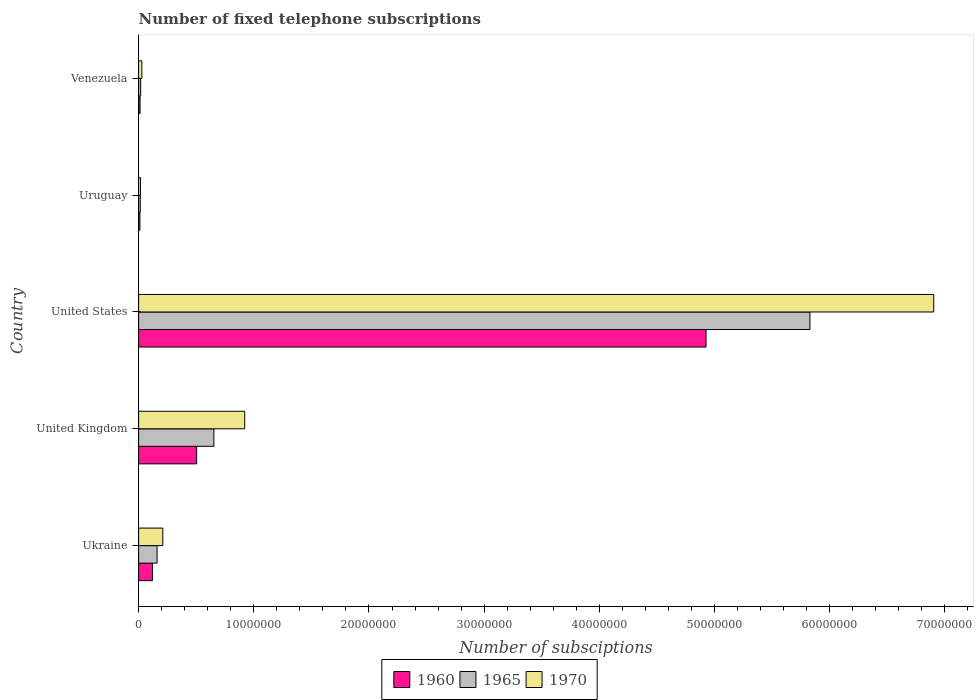How many groups of bars are there?
Your answer should be very brief. 5. Are the number of bars on each tick of the Y-axis equal?
Your response must be concise. Yes. How many bars are there on the 5th tick from the bottom?
Your answer should be compact. 3. In how many cases, is the number of bars for a given country not equal to the number of legend labels?
Give a very brief answer. 0. Across all countries, what is the maximum number of fixed telephone subscriptions in 1960?
Your response must be concise. 4.93e+07. In which country was the number of fixed telephone subscriptions in 1965 minimum?
Your answer should be compact. Uruguay. What is the total number of fixed telephone subscriptions in 1970 in the graph?
Your answer should be compact. 8.08e+07. What is the difference between the number of fixed telephone subscriptions in 1965 in Ukraine and that in United States?
Offer a terse response. -5.67e+07. What is the difference between the number of fixed telephone subscriptions in 1960 in United States and the number of fixed telephone subscriptions in 1965 in Uruguay?
Your answer should be very brief. 4.91e+07. What is the average number of fixed telephone subscriptions in 1960 per country?
Your response must be concise. 1.11e+07. What is the difference between the number of fixed telephone subscriptions in 1965 and number of fixed telephone subscriptions in 1960 in United States?
Your response must be concise. 9.02e+06. What is the ratio of the number of fixed telephone subscriptions in 1970 in United Kingdom to that in Venezuela?
Offer a very short reply. 33.02. What is the difference between the highest and the second highest number of fixed telephone subscriptions in 1965?
Offer a very short reply. 5.18e+07. What is the difference between the highest and the lowest number of fixed telephone subscriptions in 1970?
Your answer should be compact. 6.89e+07. Is the sum of the number of fixed telephone subscriptions in 1970 in United Kingdom and Venezuela greater than the maximum number of fixed telephone subscriptions in 1960 across all countries?
Provide a succinct answer. No. What does the 1st bar from the top in Ukraine represents?
Provide a short and direct response. 1970. What does the 3rd bar from the bottom in Ukraine represents?
Your answer should be very brief. 1970. Are all the bars in the graph horizontal?
Your answer should be very brief. Yes. How many countries are there in the graph?
Your answer should be very brief. 5. What is the difference between two consecutive major ticks on the X-axis?
Give a very brief answer. 1.00e+07. Are the values on the major ticks of X-axis written in scientific E-notation?
Your response must be concise. No. Does the graph contain any zero values?
Provide a succinct answer. No. Does the graph contain grids?
Your answer should be compact. No. Where does the legend appear in the graph?
Your response must be concise. Bottom center. How are the legend labels stacked?
Your response must be concise. Horizontal. What is the title of the graph?
Your response must be concise. Number of fixed telephone subscriptions. Does "1968" appear as one of the legend labels in the graph?
Keep it short and to the point. No. What is the label or title of the X-axis?
Offer a very short reply. Number of subsciptions. What is the label or title of the Y-axis?
Offer a terse response. Country. What is the Number of subsciptions in 1960 in Ukraine?
Provide a short and direct response. 1.20e+06. What is the Number of subsciptions of 1965 in Ukraine?
Offer a very short reply. 1.60e+06. What is the Number of subsciptions in 1970 in Ukraine?
Make the answer very short. 2.10e+06. What is the Number of subsciptions of 1960 in United Kingdom?
Give a very brief answer. 5.04e+06. What is the Number of subsciptions in 1965 in United Kingdom?
Keep it short and to the point. 6.53e+06. What is the Number of subsciptions in 1970 in United Kingdom?
Offer a very short reply. 9.21e+06. What is the Number of subsciptions of 1960 in United States?
Your answer should be compact. 4.93e+07. What is the Number of subsciptions of 1965 in United States?
Provide a short and direct response. 5.83e+07. What is the Number of subsciptions in 1970 in United States?
Offer a very short reply. 6.90e+07. What is the Number of subsciptions of 1965 in Uruguay?
Offer a terse response. 1.42e+05. What is the Number of subsciptions of 1960 in Venezuela?
Keep it short and to the point. 1.25e+05. What is the Number of subsciptions of 1965 in Venezuela?
Your answer should be compact. 1.78e+05. What is the Number of subsciptions in 1970 in Venezuela?
Your response must be concise. 2.79e+05. Across all countries, what is the maximum Number of subsciptions in 1960?
Give a very brief answer. 4.93e+07. Across all countries, what is the maximum Number of subsciptions in 1965?
Provide a succinct answer. 5.83e+07. Across all countries, what is the maximum Number of subsciptions of 1970?
Offer a terse response. 6.90e+07. Across all countries, what is the minimum Number of subsciptions in 1960?
Keep it short and to the point. 1.10e+05. Across all countries, what is the minimum Number of subsciptions in 1965?
Make the answer very short. 1.42e+05. Across all countries, what is the minimum Number of subsciptions of 1970?
Keep it short and to the point. 1.60e+05. What is the total Number of subsciptions of 1960 in the graph?
Offer a very short reply. 5.57e+07. What is the total Number of subsciptions of 1965 in the graph?
Provide a succinct answer. 6.67e+07. What is the total Number of subsciptions in 1970 in the graph?
Offer a terse response. 8.08e+07. What is the difference between the Number of subsciptions in 1960 in Ukraine and that in United Kingdom?
Give a very brief answer. -3.84e+06. What is the difference between the Number of subsciptions of 1965 in Ukraine and that in United Kingdom?
Offer a very short reply. -4.93e+06. What is the difference between the Number of subsciptions in 1970 in Ukraine and that in United Kingdom?
Offer a very short reply. -7.11e+06. What is the difference between the Number of subsciptions of 1960 in Ukraine and that in United States?
Offer a very short reply. -4.81e+07. What is the difference between the Number of subsciptions of 1965 in Ukraine and that in United States?
Keep it short and to the point. -5.67e+07. What is the difference between the Number of subsciptions in 1970 in Ukraine and that in United States?
Provide a short and direct response. -6.69e+07. What is the difference between the Number of subsciptions of 1960 in Ukraine and that in Uruguay?
Your response must be concise. 1.09e+06. What is the difference between the Number of subsciptions of 1965 in Ukraine and that in Uruguay?
Ensure brevity in your answer.  1.46e+06. What is the difference between the Number of subsciptions in 1970 in Ukraine and that in Uruguay?
Provide a short and direct response. 1.94e+06. What is the difference between the Number of subsciptions of 1960 in Ukraine and that in Venezuela?
Offer a very short reply. 1.08e+06. What is the difference between the Number of subsciptions in 1965 in Ukraine and that in Venezuela?
Give a very brief answer. 1.42e+06. What is the difference between the Number of subsciptions of 1970 in Ukraine and that in Venezuela?
Offer a terse response. 1.82e+06. What is the difference between the Number of subsciptions in 1960 in United Kingdom and that in United States?
Provide a succinct answer. -4.42e+07. What is the difference between the Number of subsciptions in 1965 in United Kingdom and that in United States?
Give a very brief answer. -5.18e+07. What is the difference between the Number of subsciptions in 1970 in United Kingdom and that in United States?
Provide a short and direct response. -5.98e+07. What is the difference between the Number of subsciptions in 1960 in United Kingdom and that in Uruguay?
Your answer should be very brief. 4.93e+06. What is the difference between the Number of subsciptions of 1965 in United Kingdom and that in Uruguay?
Offer a very short reply. 6.39e+06. What is the difference between the Number of subsciptions of 1970 in United Kingdom and that in Uruguay?
Make the answer very short. 9.05e+06. What is the difference between the Number of subsciptions in 1960 in United Kingdom and that in Venezuela?
Provide a succinct answer. 4.91e+06. What is the difference between the Number of subsciptions of 1965 in United Kingdom and that in Venezuela?
Your answer should be very brief. 6.36e+06. What is the difference between the Number of subsciptions of 1970 in United Kingdom and that in Venezuela?
Offer a terse response. 8.93e+06. What is the difference between the Number of subsciptions of 1960 in United States and that in Uruguay?
Offer a terse response. 4.92e+07. What is the difference between the Number of subsciptions in 1965 in United States and that in Uruguay?
Make the answer very short. 5.81e+07. What is the difference between the Number of subsciptions in 1970 in United States and that in Uruguay?
Keep it short and to the point. 6.89e+07. What is the difference between the Number of subsciptions in 1960 in United States and that in Venezuela?
Offer a terse response. 4.91e+07. What is the difference between the Number of subsciptions of 1965 in United States and that in Venezuela?
Your answer should be very brief. 5.81e+07. What is the difference between the Number of subsciptions of 1970 in United States and that in Venezuela?
Your response must be concise. 6.88e+07. What is the difference between the Number of subsciptions in 1960 in Uruguay and that in Venezuela?
Your response must be concise. -1.50e+04. What is the difference between the Number of subsciptions in 1965 in Uruguay and that in Venezuela?
Ensure brevity in your answer.  -3.60e+04. What is the difference between the Number of subsciptions of 1970 in Uruguay and that in Venezuela?
Offer a very short reply. -1.19e+05. What is the difference between the Number of subsciptions in 1960 in Ukraine and the Number of subsciptions in 1965 in United Kingdom?
Give a very brief answer. -5.33e+06. What is the difference between the Number of subsciptions in 1960 in Ukraine and the Number of subsciptions in 1970 in United Kingdom?
Provide a succinct answer. -8.01e+06. What is the difference between the Number of subsciptions of 1965 in Ukraine and the Number of subsciptions of 1970 in United Kingdom?
Provide a succinct answer. -7.61e+06. What is the difference between the Number of subsciptions of 1960 in Ukraine and the Number of subsciptions of 1965 in United States?
Your response must be concise. -5.71e+07. What is the difference between the Number of subsciptions in 1960 in Ukraine and the Number of subsciptions in 1970 in United States?
Provide a succinct answer. -6.78e+07. What is the difference between the Number of subsciptions in 1965 in Ukraine and the Number of subsciptions in 1970 in United States?
Offer a very short reply. -6.74e+07. What is the difference between the Number of subsciptions of 1960 in Ukraine and the Number of subsciptions of 1965 in Uruguay?
Offer a terse response. 1.06e+06. What is the difference between the Number of subsciptions of 1960 in Ukraine and the Number of subsciptions of 1970 in Uruguay?
Offer a very short reply. 1.04e+06. What is the difference between the Number of subsciptions in 1965 in Ukraine and the Number of subsciptions in 1970 in Uruguay?
Your response must be concise. 1.44e+06. What is the difference between the Number of subsciptions of 1960 in Ukraine and the Number of subsciptions of 1965 in Venezuela?
Ensure brevity in your answer.  1.02e+06. What is the difference between the Number of subsciptions in 1960 in Ukraine and the Number of subsciptions in 1970 in Venezuela?
Provide a short and direct response. 9.21e+05. What is the difference between the Number of subsciptions in 1965 in Ukraine and the Number of subsciptions in 1970 in Venezuela?
Your answer should be compact. 1.32e+06. What is the difference between the Number of subsciptions of 1960 in United Kingdom and the Number of subsciptions of 1965 in United States?
Make the answer very short. -5.33e+07. What is the difference between the Number of subsciptions in 1960 in United Kingdom and the Number of subsciptions in 1970 in United States?
Your response must be concise. -6.40e+07. What is the difference between the Number of subsciptions of 1965 in United Kingdom and the Number of subsciptions of 1970 in United States?
Provide a short and direct response. -6.25e+07. What is the difference between the Number of subsciptions of 1960 in United Kingdom and the Number of subsciptions of 1965 in Uruguay?
Give a very brief answer. 4.90e+06. What is the difference between the Number of subsciptions of 1960 in United Kingdom and the Number of subsciptions of 1970 in Uruguay?
Give a very brief answer. 4.88e+06. What is the difference between the Number of subsciptions of 1965 in United Kingdom and the Number of subsciptions of 1970 in Uruguay?
Your response must be concise. 6.37e+06. What is the difference between the Number of subsciptions of 1960 in United Kingdom and the Number of subsciptions of 1965 in Venezuela?
Offer a terse response. 4.86e+06. What is the difference between the Number of subsciptions in 1960 in United Kingdom and the Number of subsciptions in 1970 in Venezuela?
Give a very brief answer. 4.76e+06. What is the difference between the Number of subsciptions in 1965 in United Kingdom and the Number of subsciptions in 1970 in Venezuela?
Your response must be concise. 6.26e+06. What is the difference between the Number of subsciptions of 1960 in United States and the Number of subsciptions of 1965 in Uruguay?
Provide a succinct answer. 4.91e+07. What is the difference between the Number of subsciptions of 1960 in United States and the Number of subsciptions of 1970 in Uruguay?
Offer a terse response. 4.91e+07. What is the difference between the Number of subsciptions of 1965 in United States and the Number of subsciptions of 1970 in Uruguay?
Provide a succinct answer. 5.81e+07. What is the difference between the Number of subsciptions of 1960 in United States and the Number of subsciptions of 1965 in Venezuela?
Offer a very short reply. 4.91e+07. What is the difference between the Number of subsciptions of 1960 in United States and the Number of subsciptions of 1970 in Venezuela?
Keep it short and to the point. 4.90e+07. What is the difference between the Number of subsciptions in 1965 in United States and the Number of subsciptions in 1970 in Venezuela?
Your answer should be very brief. 5.80e+07. What is the difference between the Number of subsciptions of 1960 in Uruguay and the Number of subsciptions of 1965 in Venezuela?
Keep it short and to the point. -6.80e+04. What is the difference between the Number of subsciptions in 1960 in Uruguay and the Number of subsciptions in 1970 in Venezuela?
Your answer should be compact. -1.69e+05. What is the difference between the Number of subsciptions in 1965 in Uruguay and the Number of subsciptions in 1970 in Venezuela?
Offer a very short reply. -1.37e+05. What is the average Number of subsciptions in 1960 per country?
Give a very brief answer. 1.11e+07. What is the average Number of subsciptions in 1965 per country?
Make the answer very short. 1.33e+07. What is the average Number of subsciptions in 1970 per country?
Your answer should be very brief. 1.62e+07. What is the difference between the Number of subsciptions of 1960 and Number of subsciptions of 1965 in Ukraine?
Your answer should be compact. -4.00e+05. What is the difference between the Number of subsciptions in 1960 and Number of subsciptions in 1970 in Ukraine?
Your answer should be very brief. -9.00e+05. What is the difference between the Number of subsciptions of 1965 and Number of subsciptions of 1970 in Ukraine?
Offer a terse response. -5.00e+05. What is the difference between the Number of subsciptions in 1960 and Number of subsciptions in 1965 in United Kingdom?
Offer a very short reply. -1.50e+06. What is the difference between the Number of subsciptions in 1960 and Number of subsciptions in 1970 in United Kingdom?
Offer a very short reply. -4.18e+06. What is the difference between the Number of subsciptions of 1965 and Number of subsciptions of 1970 in United Kingdom?
Your answer should be very brief. -2.68e+06. What is the difference between the Number of subsciptions of 1960 and Number of subsciptions of 1965 in United States?
Your answer should be very brief. -9.02e+06. What is the difference between the Number of subsciptions in 1960 and Number of subsciptions in 1970 in United States?
Provide a short and direct response. -1.98e+07. What is the difference between the Number of subsciptions in 1965 and Number of subsciptions in 1970 in United States?
Make the answer very short. -1.08e+07. What is the difference between the Number of subsciptions of 1960 and Number of subsciptions of 1965 in Uruguay?
Your answer should be compact. -3.20e+04. What is the difference between the Number of subsciptions in 1965 and Number of subsciptions in 1970 in Uruguay?
Make the answer very short. -1.80e+04. What is the difference between the Number of subsciptions in 1960 and Number of subsciptions in 1965 in Venezuela?
Your response must be concise. -5.30e+04. What is the difference between the Number of subsciptions of 1960 and Number of subsciptions of 1970 in Venezuela?
Your response must be concise. -1.54e+05. What is the difference between the Number of subsciptions in 1965 and Number of subsciptions in 1970 in Venezuela?
Offer a terse response. -1.01e+05. What is the ratio of the Number of subsciptions of 1960 in Ukraine to that in United Kingdom?
Ensure brevity in your answer.  0.24. What is the ratio of the Number of subsciptions of 1965 in Ukraine to that in United Kingdom?
Provide a succinct answer. 0.24. What is the ratio of the Number of subsciptions of 1970 in Ukraine to that in United Kingdom?
Your answer should be compact. 0.23. What is the ratio of the Number of subsciptions of 1960 in Ukraine to that in United States?
Your response must be concise. 0.02. What is the ratio of the Number of subsciptions in 1965 in Ukraine to that in United States?
Your answer should be very brief. 0.03. What is the ratio of the Number of subsciptions of 1970 in Ukraine to that in United States?
Your answer should be compact. 0.03. What is the ratio of the Number of subsciptions in 1960 in Ukraine to that in Uruguay?
Your answer should be very brief. 10.91. What is the ratio of the Number of subsciptions in 1965 in Ukraine to that in Uruguay?
Your answer should be very brief. 11.27. What is the ratio of the Number of subsciptions in 1970 in Ukraine to that in Uruguay?
Offer a very short reply. 13.12. What is the ratio of the Number of subsciptions of 1960 in Ukraine to that in Venezuela?
Ensure brevity in your answer.  9.6. What is the ratio of the Number of subsciptions in 1965 in Ukraine to that in Venezuela?
Your answer should be very brief. 8.99. What is the ratio of the Number of subsciptions in 1970 in Ukraine to that in Venezuela?
Ensure brevity in your answer.  7.53. What is the ratio of the Number of subsciptions of 1960 in United Kingdom to that in United States?
Make the answer very short. 0.1. What is the ratio of the Number of subsciptions in 1965 in United Kingdom to that in United States?
Give a very brief answer. 0.11. What is the ratio of the Number of subsciptions of 1970 in United Kingdom to that in United States?
Offer a terse response. 0.13. What is the ratio of the Number of subsciptions in 1960 in United Kingdom to that in Uruguay?
Your response must be concise. 45.79. What is the ratio of the Number of subsciptions of 1965 in United Kingdom to that in Uruguay?
Offer a terse response. 46.01. What is the ratio of the Number of subsciptions in 1970 in United Kingdom to that in Uruguay?
Your response must be concise. 57.58. What is the ratio of the Number of subsciptions in 1960 in United Kingdom to that in Venezuela?
Ensure brevity in your answer.  40.3. What is the ratio of the Number of subsciptions of 1965 in United Kingdom to that in Venezuela?
Provide a succinct answer. 36.71. What is the ratio of the Number of subsciptions of 1970 in United Kingdom to that in Venezuela?
Make the answer very short. 33.02. What is the ratio of the Number of subsciptions in 1960 in United States to that in Uruguay?
Offer a terse response. 447.9. What is the ratio of the Number of subsciptions in 1965 in United States to that in Uruguay?
Ensure brevity in your answer.  410.49. What is the ratio of the Number of subsciptions of 1970 in United States to that in Uruguay?
Your answer should be very brief. 431.49. What is the ratio of the Number of subsciptions of 1960 in United States to that in Venezuela?
Your answer should be very brief. 394.15. What is the ratio of the Number of subsciptions of 1965 in United States to that in Venezuela?
Provide a short and direct response. 327.47. What is the ratio of the Number of subsciptions in 1970 in United States to that in Venezuela?
Give a very brief answer. 247.45. What is the ratio of the Number of subsciptions in 1960 in Uruguay to that in Venezuela?
Offer a terse response. 0.88. What is the ratio of the Number of subsciptions of 1965 in Uruguay to that in Venezuela?
Your response must be concise. 0.8. What is the ratio of the Number of subsciptions in 1970 in Uruguay to that in Venezuela?
Your answer should be compact. 0.57. What is the difference between the highest and the second highest Number of subsciptions in 1960?
Offer a very short reply. 4.42e+07. What is the difference between the highest and the second highest Number of subsciptions of 1965?
Keep it short and to the point. 5.18e+07. What is the difference between the highest and the second highest Number of subsciptions in 1970?
Keep it short and to the point. 5.98e+07. What is the difference between the highest and the lowest Number of subsciptions of 1960?
Provide a succinct answer. 4.92e+07. What is the difference between the highest and the lowest Number of subsciptions of 1965?
Your answer should be compact. 5.81e+07. What is the difference between the highest and the lowest Number of subsciptions in 1970?
Your answer should be compact. 6.89e+07. 